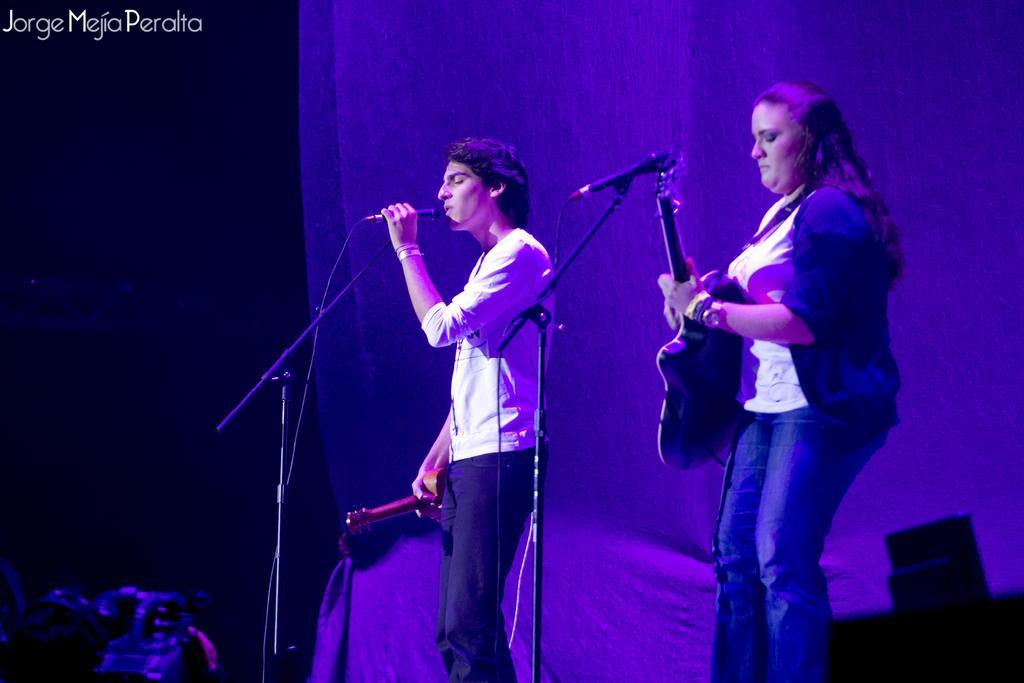How would you summarize this image in a sentence or two? This picture is clicked at a show. There are two people standing in the image. The woman at the left corner is playing guitar. In front of her there is a microphone and its stand. The man beside her is holding a guitar in his right hand and microphone in his left hand. He is singing. Behind them there is cloth. The background is dark. At the above left corner of the image there is some text. 